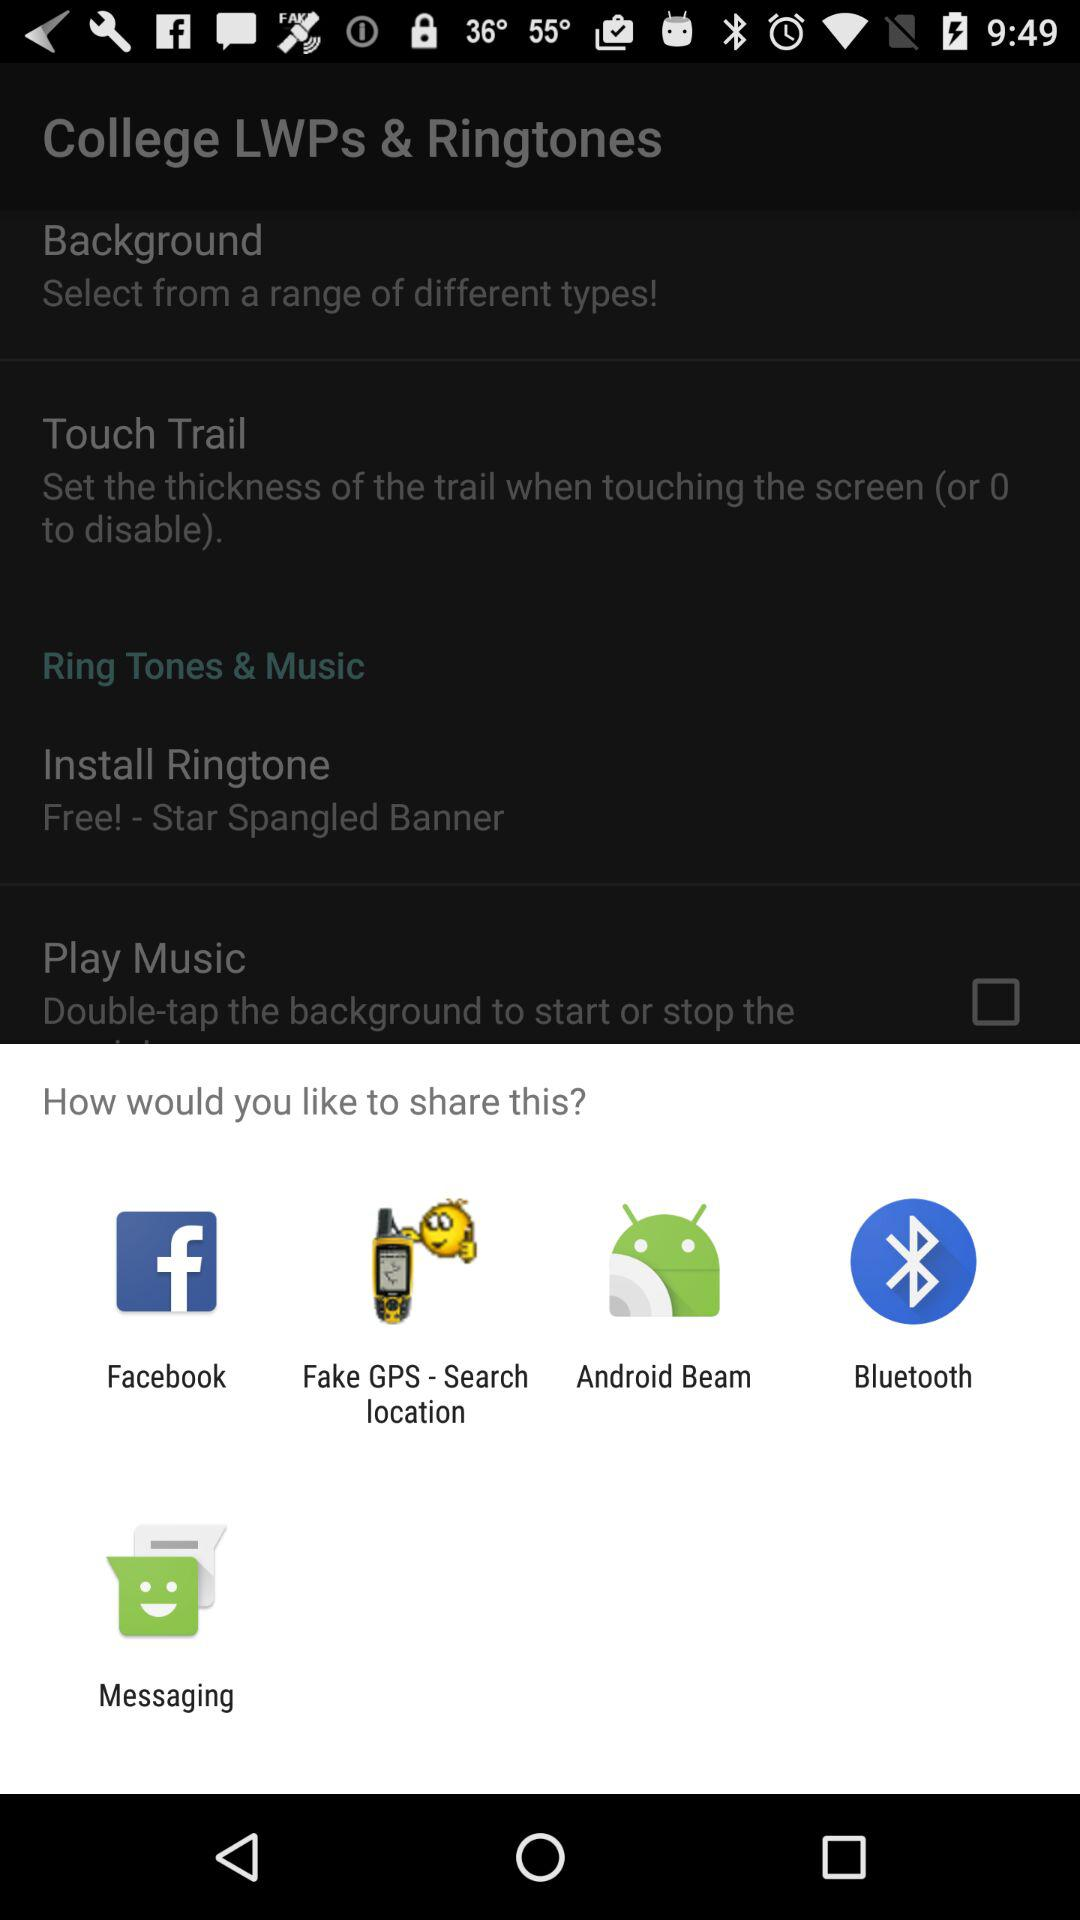What are the sharing options? The sharing options are "Facebook", "Fake GPS - Search location", "Android Beam", "Bluetooth", and "Messaging". 